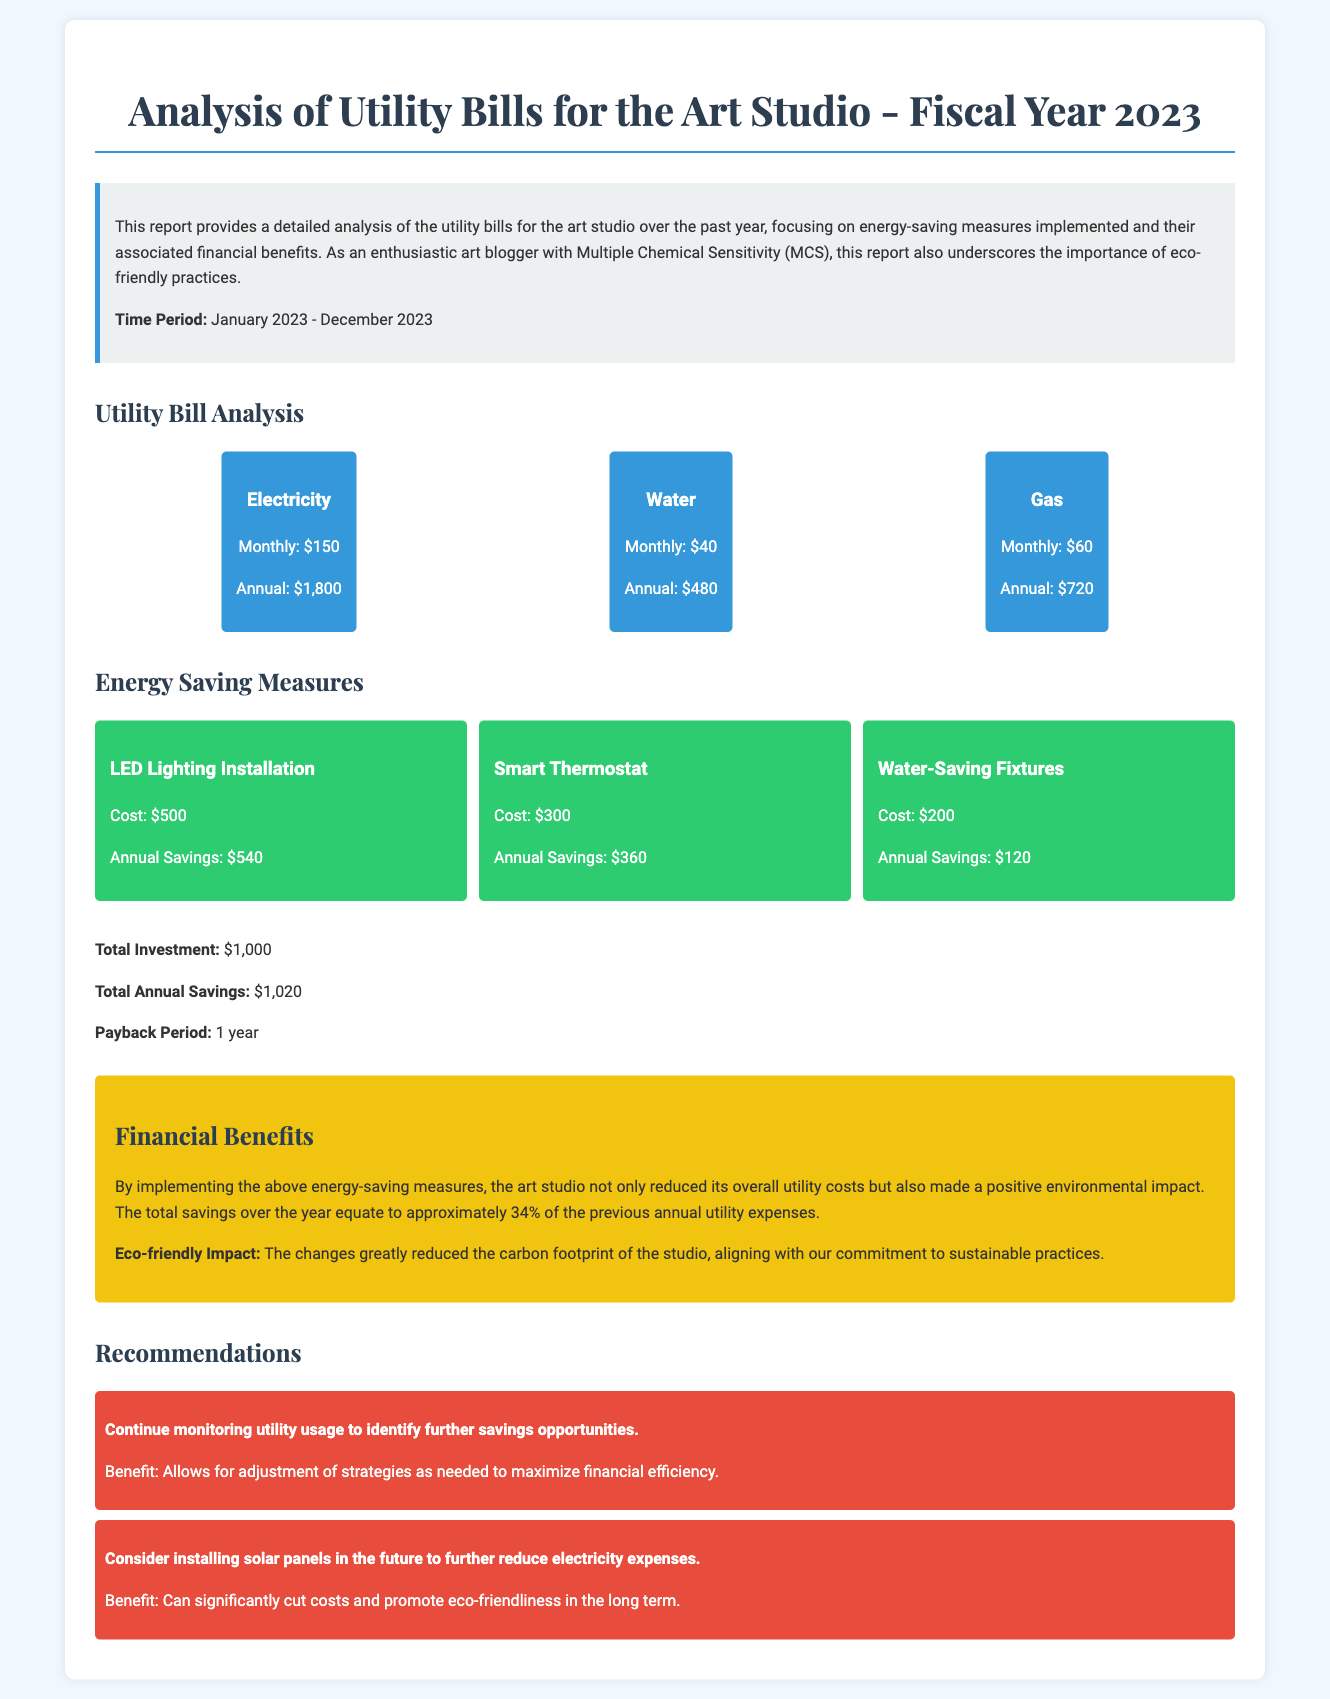What is the total annual cost of electricity? The total annual cost of electricity is listed under the utility summary as $1,800.
Answer: $1,800 What is the payback period for the energy-saving measures? The payback period is calculated based on the total investment and total annual savings, which is stated as 1 year.
Answer: 1 year How much was saved annually from LED lighting installation? The annual savings for LED lighting installation is specifically mentioned as $540.
Answer: $540 What is the total investment in energy-saving measures? The total investment is explicitly provided in the report and amounts to $1,000.
Answer: $1,000 What is the total annual savings from all implemented measures? The report summarizes the total annual savings after implementing measures as $1,020.
Answer: $1,020 What percentage of previous annual utility expenses does the savings represent? The document states that savings equate to approximately 34% of previous annual utility expenses.
Answer: 34% Which energy-saving measure had the lowest annual savings? The water-saving fixtures had the lowest annual savings, which is $120.
Answer: $120 What is one of the recommendations for future improvements? One recommendation is to consider installing solar panels in the future to reduce electricity expenses.
Answer: Install solar panels What is highlighted as an eco-friendly impact of the energy-saving measures? The report emphasizes a significant reduction in the carbon footprint due to the changes made.
Answer: Reduced carbon footprint 